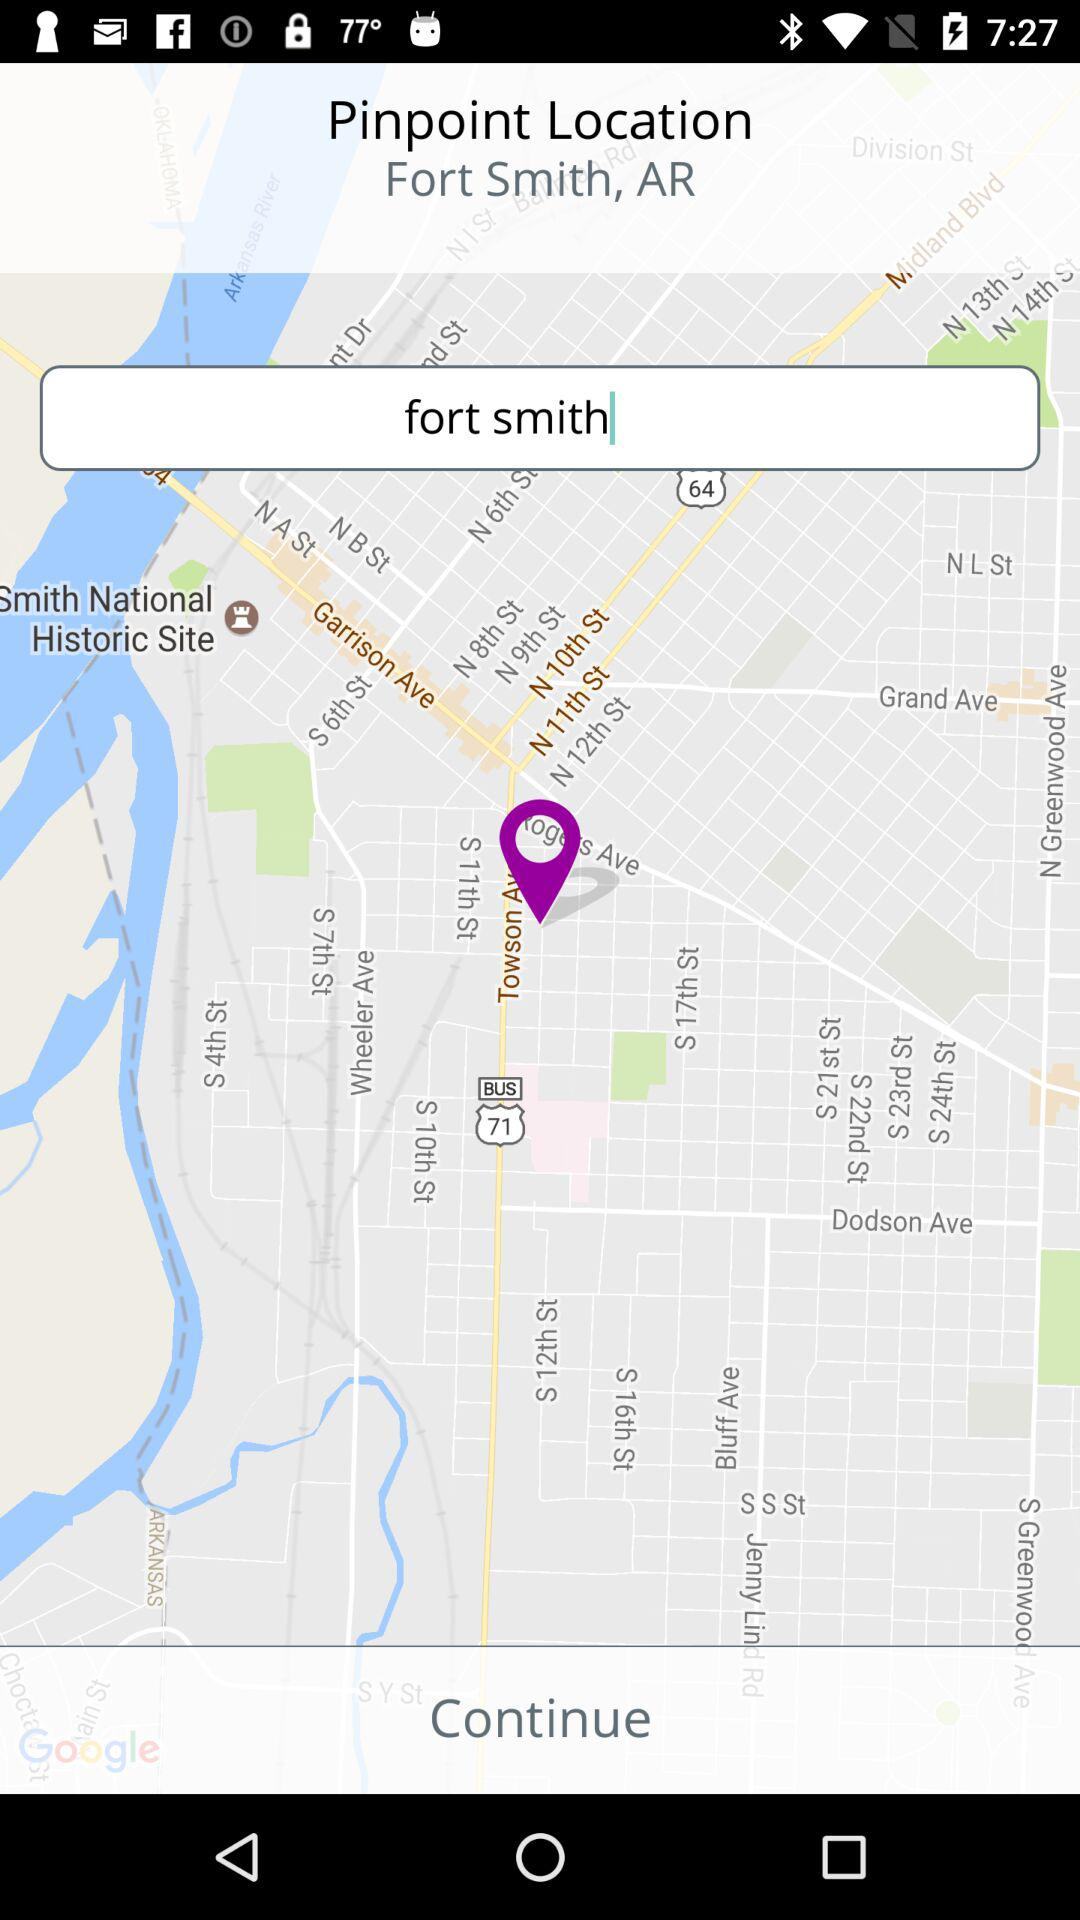What is the entered location? The entered location is Fort Smith. 